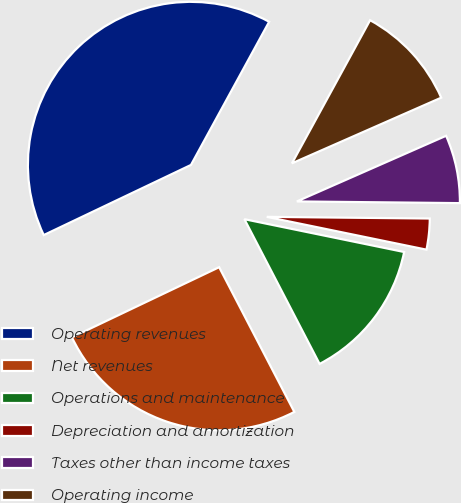Convert chart. <chart><loc_0><loc_0><loc_500><loc_500><pie_chart><fcel>Operating revenues<fcel>Net revenues<fcel>Operations and maintenance<fcel>Depreciation and amortization<fcel>Taxes other than income taxes<fcel>Operating income<nl><fcel>40.03%<fcel>25.55%<fcel>14.15%<fcel>3.06%<fcel>6.76%<fcel>10.45%<nl></chart> 